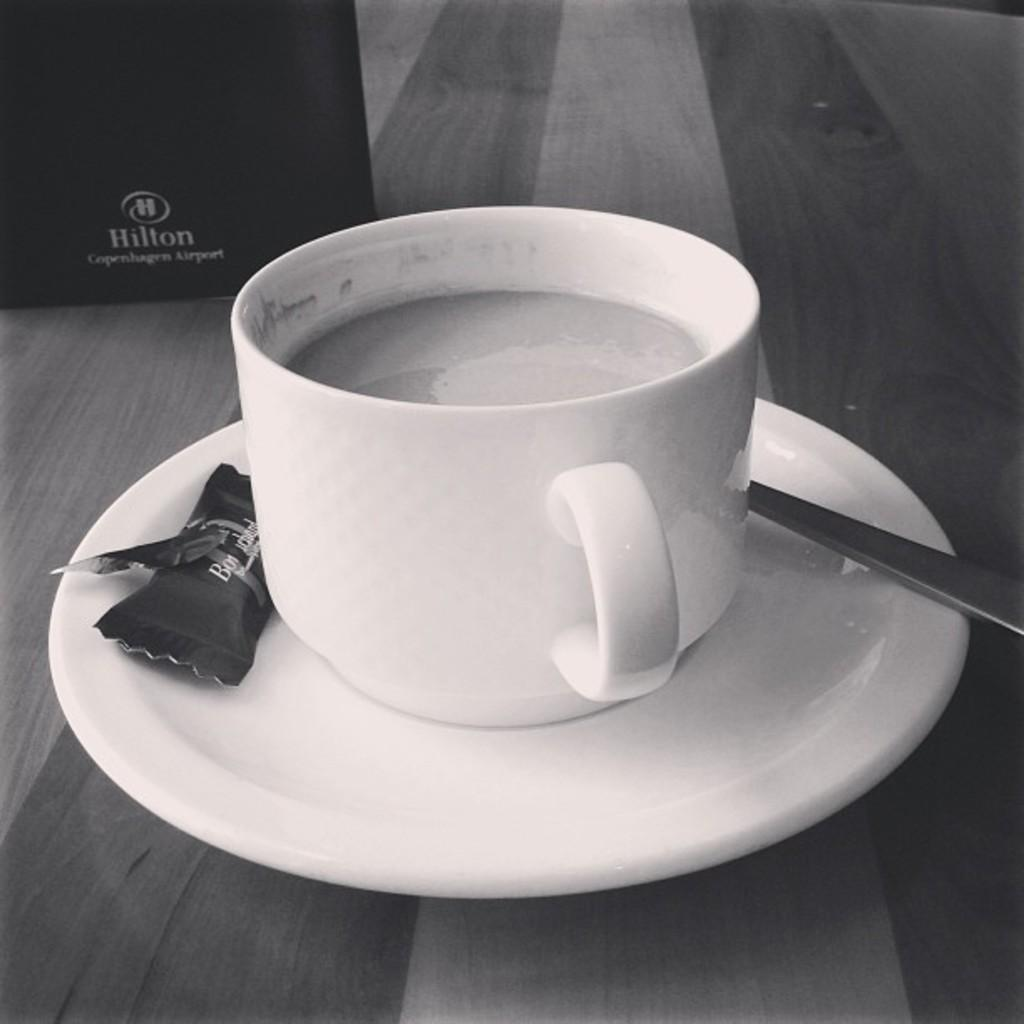What is present in the image that can be used for drinking? There is a cup in the image that can be used for drinking. What is present in the image that can be used for stirring or scooping? There is a spoon in the image that can be used for stirring or scooping. What is covering the saucer in the image? There is a cover on the saucer in the image. What is inside the cup in the image? There is a drink in the cup. What type of jewel can be seen on the spoon in the image? There is no jewel present on the spoon in the image. How many mice are visible on the saucer in the image? There are no mice present on the saucer or in the image. 